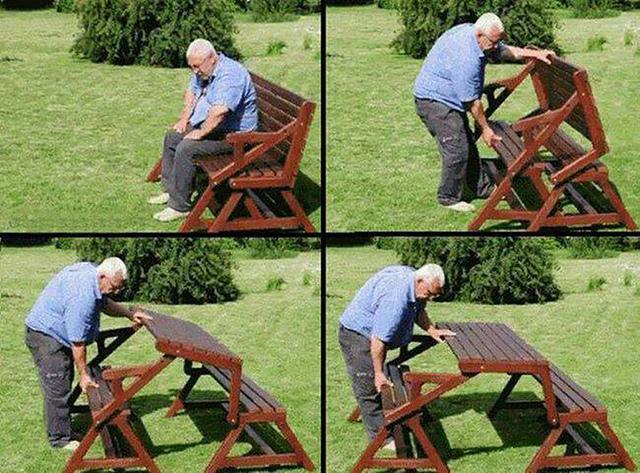How many dining tables are visible?
Give a very brief answer. 2. How many benches can you see?
Give a very brief answer. 3. How many people are there?
Give a very brief answer. 4. How many white cars are there?
Give a very brief answer. 0. 